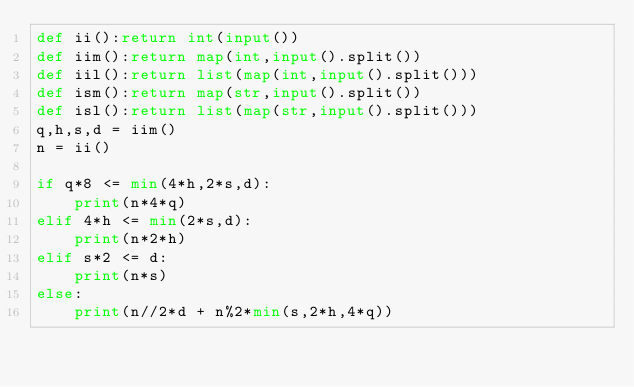Convert code to text. <code><loc_0><loc_0><loc_500><loc_500><_Python_>def ii():return int(input())
def iim():return map(int,input().split())
def iil():return list(map(int,input().split()))
def ism():return map(str,input().split())
def isl():return list(map(str,input().split()))
q,h,s,d = iim()
n = ii()

if q*8 <= min(4*h,2*s,d):
    print(n*4*q)
elif 4*h <= min(2*s,d):
    print(n*2*h)
elif s*2 <= d:
    print(n*s)
else:
    print(n//2*d + n%2*min(s,2*h,4*q))</code> 